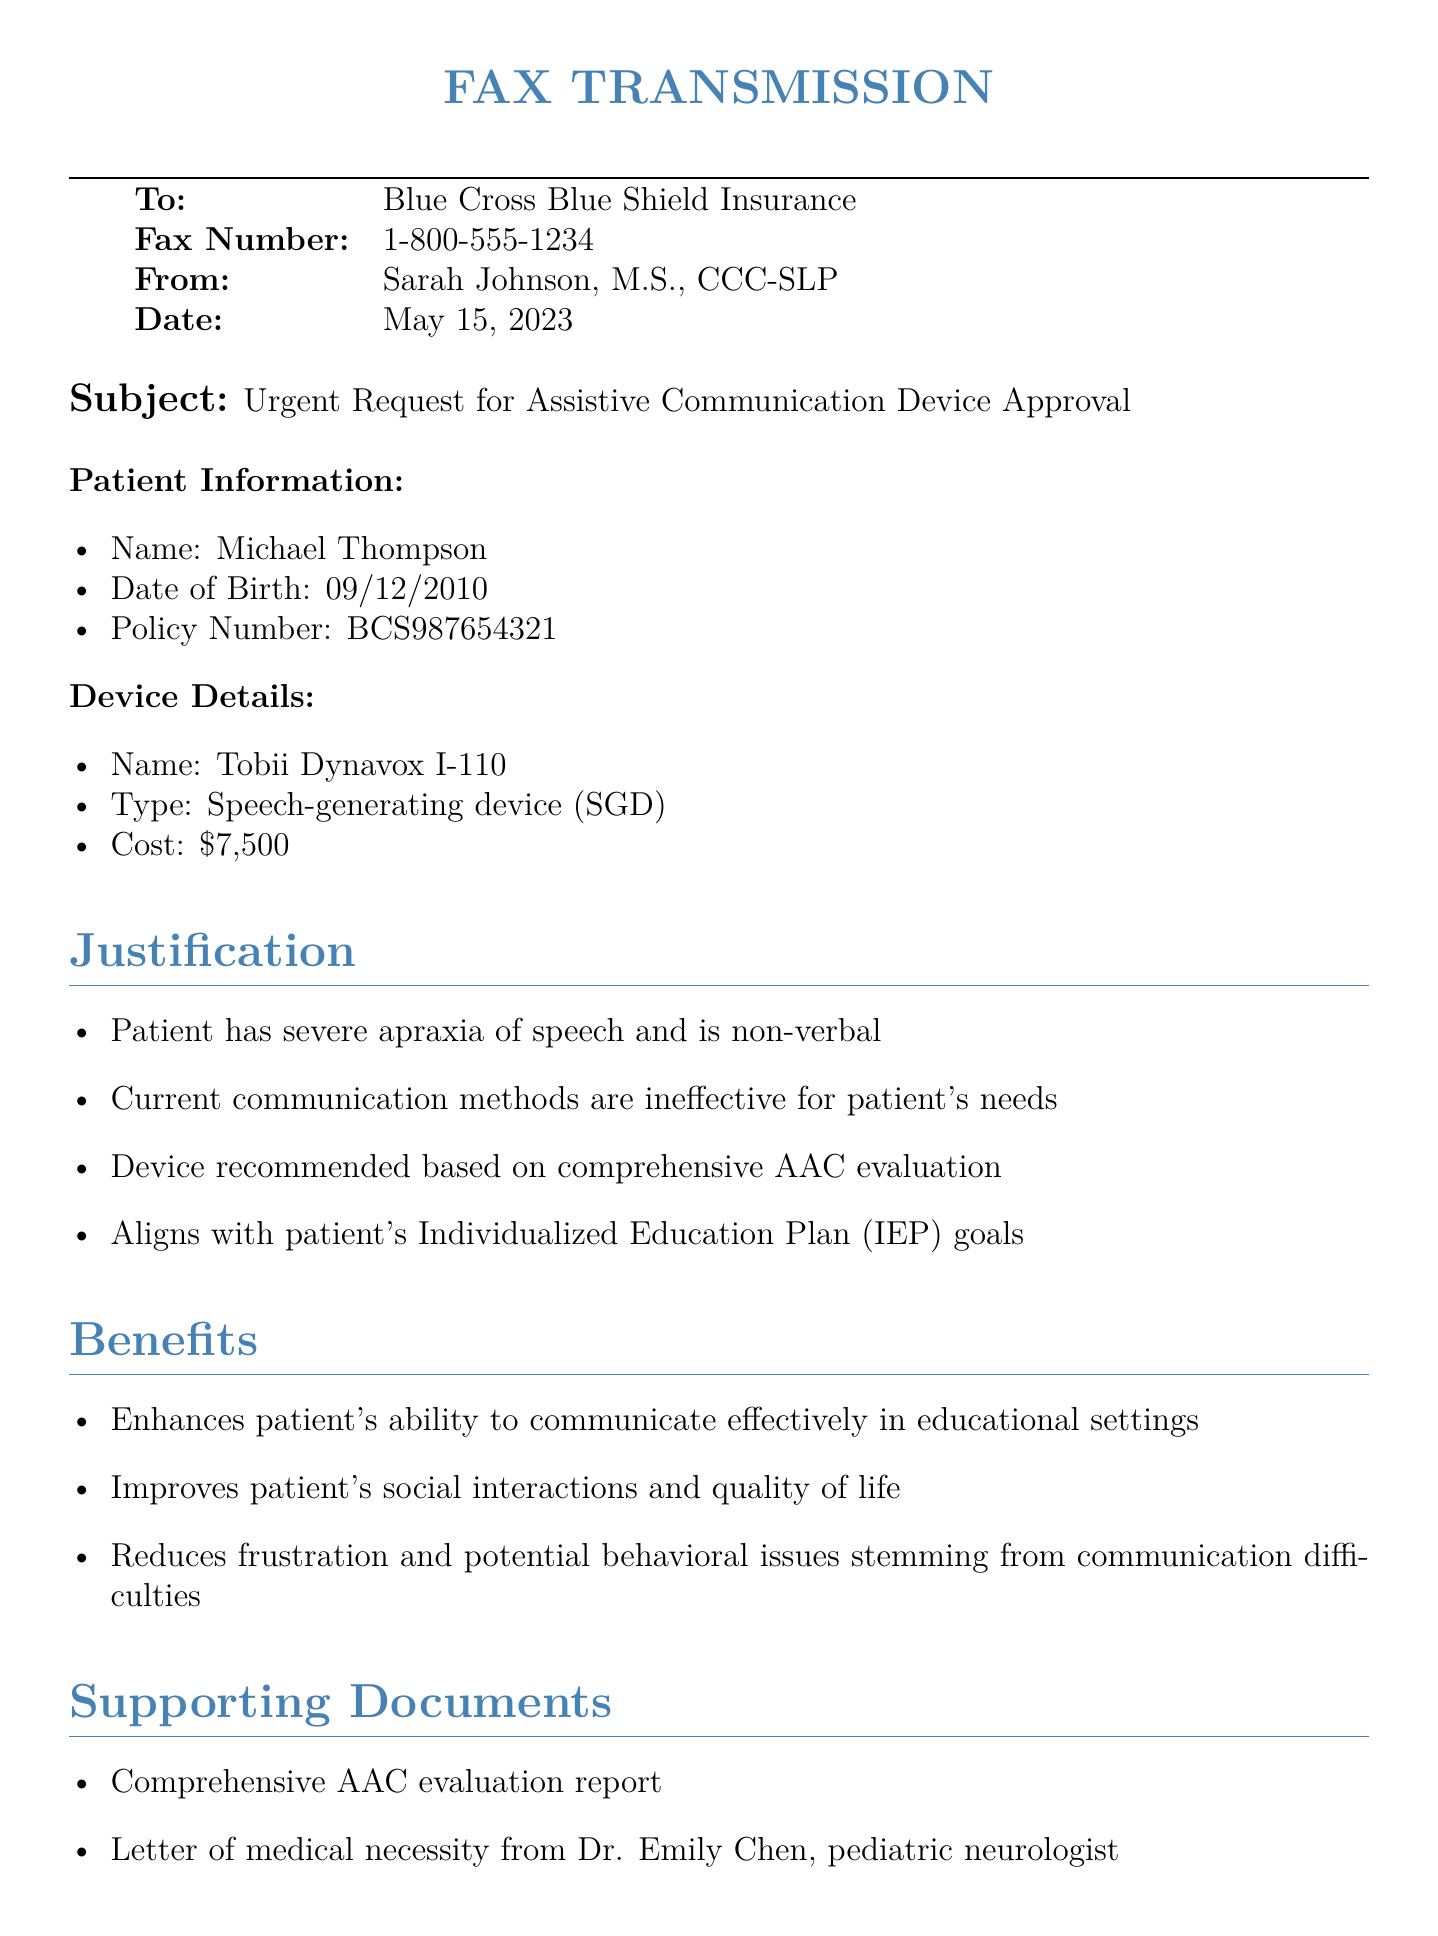What is the patient's name? The document clearly states the patient's name in the Patient Information section.
Answer: Michael Thompson What is the device type requested? The requested device type can be found in the Device Details section of the document.
Answer: Speech-generating device (SGD) What is the cost of the Tobii Dynavox I-110? The cost is listed in the Device Details section and is a specific figure.
Answer: $7,500 Who is the author of the fax? The author's name is mentioned at the bottom of the document after the urgency statement.
Answer: Sarah Johnson, M.S., CCC-SLP What condition does the patient have? The patient's condition is specified in the Justification section of the fax.
Answer: Severe apraxia of speech What is the urgency statement regarding the device approval? The urgency statement is provided in a specific section of the document and highlights the importance of timely action.
Answer: Immediate approval is crucial to ensure the patient can effectively participate in upcoming IEP meetings What supporting document is included with the fax? The Supporting Documents section enumerates various documents that accompany the request.
Answer: Comprehensive AAC evaluation report On what date was the fax sent? The date can be found prominently displayed at the top of the fax.
Answer: May 15, 2023 What is the patient's date of birth? This information is clearly stated in the Patient Information section.
Answer: 09/12/2010 